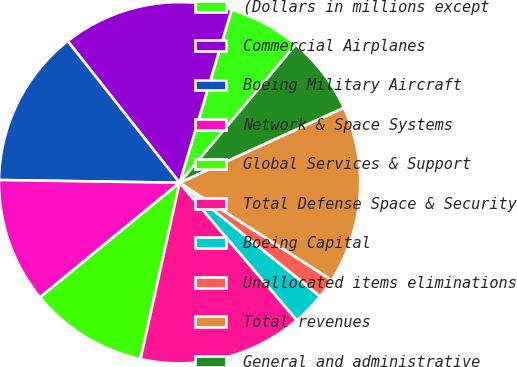Convert chart to OTSL. <chart><loc_0><loc_0><loc_500><loc_500><pie_chart><fcel>(Dollars in millions except<fcel>Commercial Airplanes<fcel>Boeing Military Aircraft<fcel>Network & Space Systems<fcel>Global Services & Support<fcel>Total Defense Space & Security<fcel>Boeing Capital<fcel>Unallocated items eliminations<fcel>Total revenues<fcel>General and administrative<nl><fcel>6.47%<fcel>15.29%<fcel>14.12%<fcel>11.18%<fcel>10.59%<fcel>14.71%<fcel>2.94%<fcel>1.76%<fcel>15.88%<fcel>7.06%<nl></chart> 